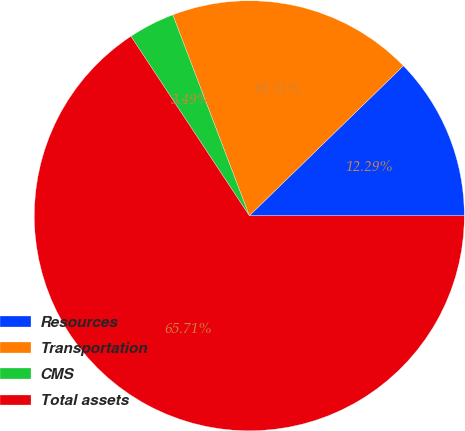<chart> <loc_0><loc_0><loc_500><loc_500><pie_chart><fcel>Resources<fcel>Transportation<fcel>CMS<fcel>Total assets<nl><fcel>12.29%<fcel>18.51%<fcel>3.49%<fcel>65.72%<nl></chart> 